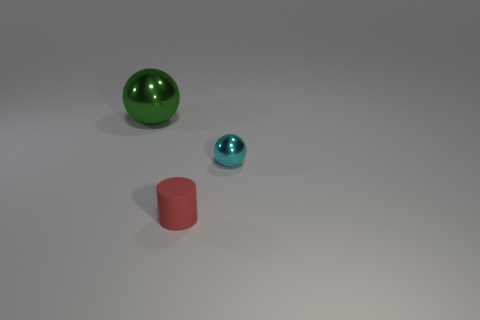Are there more cyan things than shiny objects?
Provide a short and direct response. No. What color is the cylinder that is the same size as the cyan object?
Offer a very short reply. Red. How many cylinders are matte things or cyan metallic things?
Give a very brief answer. 1. There is a cyan shiny thing; is its shape the same as the shiny thing that is behind the small cyan ball?
Your response must be concise. Yes. What number of cyan objects are the same size as the green metallic ball?
Offer a terse response. 0. There is a thing that is in front of the small cyan sphere; does it have the same shape as the metallic object behind the small cyan sphere?
Provide a short and direct response. No. There is a shiny sphere that is to the left of the object in front of the cyan metallic object; what color is it?
Offer a terse response. Green. What is the color of the other thing that is the same shape as the big green thing?
Offer a very short reply. Cyan. Is there anything else that is made of the same material as the small red thing?
Make the answer very short. No. What size is the other thing that is the same shape as the small metallic object?
Provide a succinct answer. Large. 